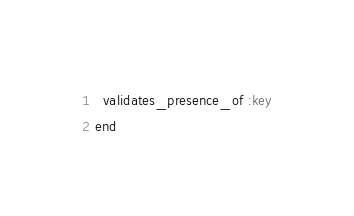Convert code to text. <code><loc_0><loc_0><loc_500><loc_500><_Ruby_>
  validates_presence_of :key
end
</code> 